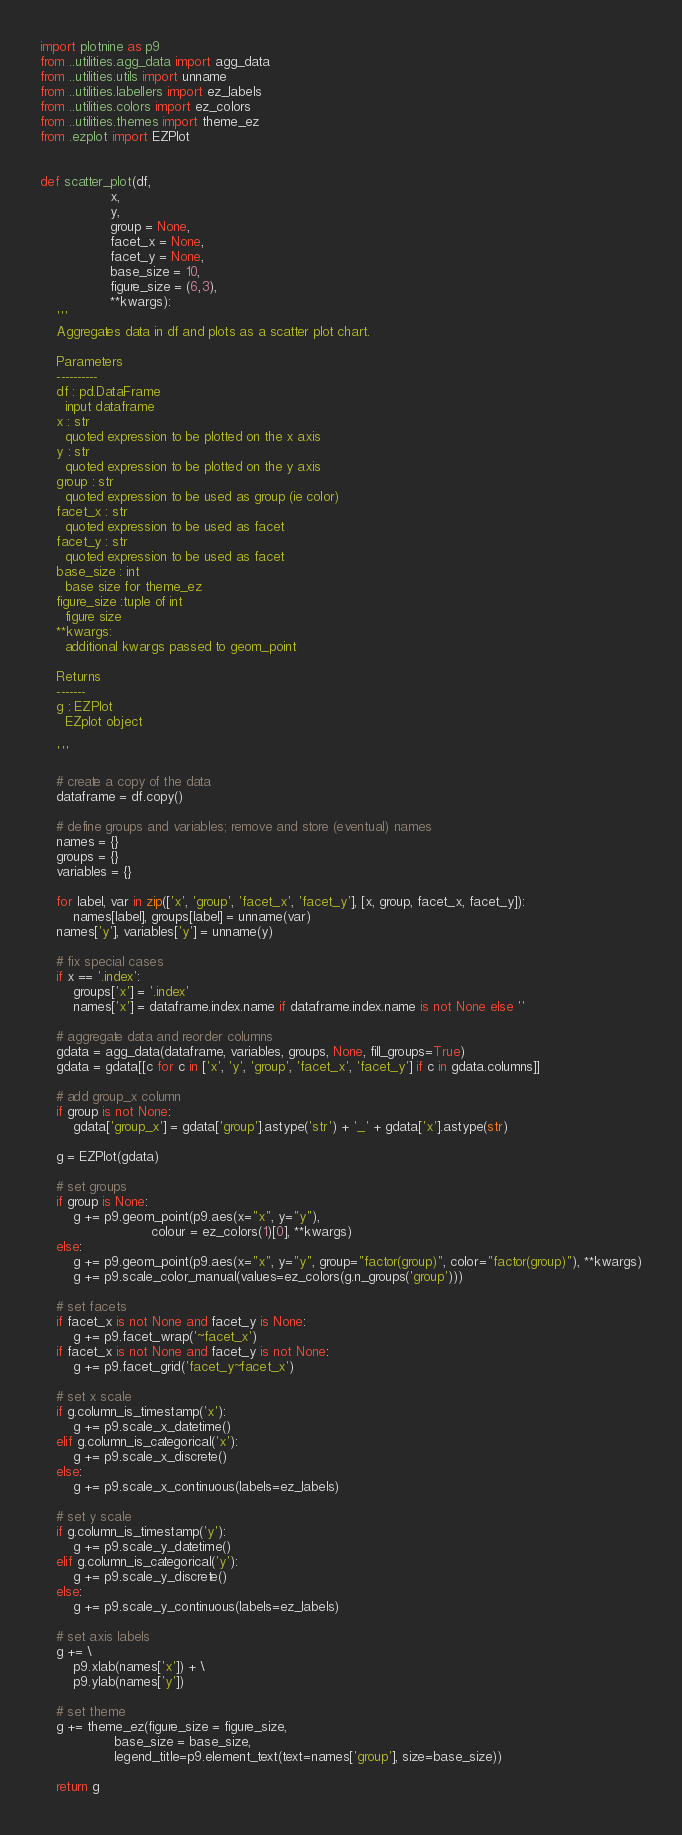Convert code to text. <code><loc_0><loc_0><loc_500><loc_500><_Python_>import plotnine as p9
from ..utilities.agg_data import agg_data
from ..utilities.utils import unname
from ..utilities.labellers import ez_labels
from ..utilities.colors import ez_colors
from ..utilities.themes import theme_ez
from .ezplot import EZPlot


def scatter_plot(df,
                 x,
                 y,
                 group = None,
                 facet_x = None,
                 facet_y = None,
                 base_size = 10,
                 figure_size = (6,3),
                 **kwargs):
    '''
    Aggregates data in df and plots as a scatter plot chart.

    Parameters
    ----------
    df : pd.DataFrame
      input dataframe
    x : str
      quoted expression to be plotted on the x axis
    y : str
      quoted expression to be plotted on the y axis
    group : str
      quoted expression to be used as group (ie color)
    facet_x : str
      quoted expression to be used as facet
    facet_y : str
      quoted expression to be used as facet
    base_size : int
      base size for theme_ez
    figure_size :tuple of int
      figure size
    **kwargs:
      additional kwargs passed to geom_point

    Returns
    -------
    g : EZPlot
      EZplot object

    '''

    # create a copy of the data
    dataframe = df.copy()

    # define groups and variables; remove and store (eventual) names
    names = {}
    groups = {}
    variables = {}

    for label, var in zip(['x', 'group', 'facet_x', 'facet_y'], [x, group, facet_x, facet_y]):
        names[label], groups[label] = unname(var)
    names['y'], variables['y'] = unname(y)

    # fix special cases
    if x == '.index':
        groups['x'] = '.index'
        names['x'] = dataframe.index.name if dataframe.index.name is not None else ''

    # aggregate data and reorder columns
    gdata = agg_data(dataframe, variables, groups, None, fill_groups=True)
    gdata = gdata[[c for c in ['x', 'y', 'group', 'facet_x', 'facet_y'] if c in gdata.columns]]

    # add group_x column
    if group is not None:
        gdata['group_x'] = gdata['group'].astype('str') + '_' + gdata['x'].astype(str)

    g = EZPlot(gdata)

    # set groups
    if group is None:
        g += p9.geom_point(p9.aes(x="x", y="y"),
                           colour = ez_colors(1)[0], **kwargs)
    else:
        g += p9.geom_point(p9.aes(x="x", y="y", group="factor(group)", color="factor(group)"), **kwargs)
        g += p9.scale_color_manual(values=ez_colors(g.n_groups('group')))

    # set facets
    if facet_x is not None and facet_y is None:
        g += p9.facet_wrap('~facet_x')
    if facet_x is not None and facet_y is not None:
        g += p9.facet_grid('facet_y~facet_x')

    # set x scale
    if g.column_is_timestamp('x'):
        g += p9.scale_x_datetime()
    elif g.column_is_categorical('x'):
        g += p9.scale_x_discrete()
    else:
        g += p9.scale_x_continuous(labels=ez_labels)

    # set y scale
    if g.column_is_timestamp('y'):
        g += p9.scale_y_datetime()
    elif g.column_is_categorical('y'):
        g += p9.scale_y_discrete()
    else:
        g += p9.scale_y_continuous(labels=ez_labels)

    # set axis labels
    g += \
        p9.xlab(names['x']) + \
        p9.ylab(names['y'])

    # set theme
    g += theme_ez(figure_size = figure_size,
                  base_size = base_size,
                  legend_title=p9.element_text(text=names['group'], size=base_size))

    return g



</code> 